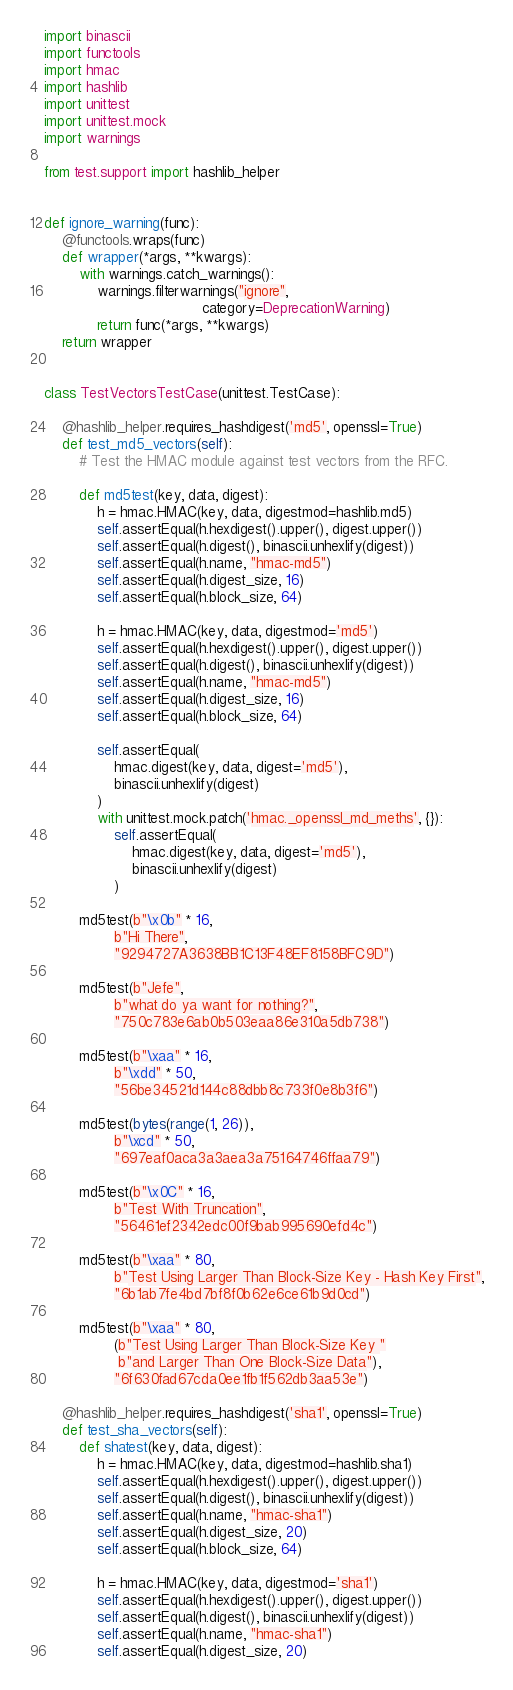Convert code to text. <code><loc_0><loc_0><loc_500><loc_500><_Python_>import binascii
import functools
import hmac
import hashlib
import unittest
import unittest.mock
import warnings

from test.support import hashlib_helper


def ignore_warning(func):
    @functools.wraps(func)
    def wrapper(*args, **kwargs):
        with warnings.catch_warnings():
            warnings.filterwarnings("ignore",
                                    category=DeprecationWarning)
            return func(*args, **kwargs)
    return wrapper


class TestVectorsTestCase(unittest.TestCase):

    @hashlib_helper.requires_hashdigest('md5', openssl=True)
    def test_md5_vectors(self):
        # Test the HMAC module against test vectors from the RFC.

        def md5test(key, data, digest):
            h = hmac.HMAC(key, data, digestmod=hashlib.md5)
            self.assertEqual(h.hexdigest().upper(), digest.upper())
            self.assertEqual(h.digest(), binascii.unhexlify(digest))
            self.assertEqual(h.name, "hmac-md5")
            self.assertEqual(h.digest_size, 16)
            self.assertEqual(h.block_size, 64)

            h = hmac.HMAC(key, data, digestmod='md5')
            self.assertEqual(h.hexdigest().upper(), digest.upper())
            self.assertEqual(h.digest(), binascii.unhexlify(digest))
            self.assertEqual(h.name, "hmac-md5")
            self.assertEqual(h.digest_size, 16)
            self.assertEqual(h.block_size, 64)

            self.assertEqual(
                hmac.digest(key, data, digest='md5'),
                binascii.unhexlify(digest)
            )
            with unittest.mock.patch('hmac._openssl_md_meths', {}):
                self.assertEqual(
                    hmac.digest(key, data, digest='md5'),
                    binascii.unhexlify(digest)
                )

        md5test(b"\x0b" * 16,
                b"Hi There",
                "9294727A3638BB1C13F48EF8158BFC9D")

        md5test(b"Jefe",
                b"what do ya want for nothing?",
                "750c783e6ab0b503eaa86e310a5db738")

        md5test(b"\xaa" * 16,
                b"\xdd" * 50,
                "56be34521d144c88dbb8c733f0e8b3f6")

        md5test(bytes(range(1, 26)),
                b"\xcd" * 50,
                "697eaf0aca3a3aea3a75164746ffaa79")

        md5test(b"\x0C" * 16,
                b"Test With Truncation",
                "56461ef2342edc00f9bab995690efd4c")

        md5test(b"\xaa" * 80,
                b"Test Using Larger Than Block-Size Key - Hash Key First",
                "6b1ab7fe4bd7bf8f0b62e6ce61b9d0cd")

        md5test(b"\xaa" * 80,
                (b"Test Using Larger Than Block-Size Key "
                 b"and Larger Than One Block-Size Data"),
                "6f630fad67cda0ee1fb1f562db3aa53e")

    @hashlib_helper.requires_hashdigest('sha1', openssl=True)
    def test_sha_vectors(self):
        def shatest(key, data, digest):
            h = hmac.HMAC(key, data, digestmod=hashlib.sha1)
            self.assertEqual(h.hexdigest().upper(), digest.upper())
            self.assertEqual(h.digest(), binascii.unhexlify(digest))
            self.assertEqual(h.name, "hmac-sha1")
            self.assertEqual(h.digest_size, 20)
            self.assertEqual(h.block_size, 64)

            h = hmac.HMAC(key, data, digestmod='sha1')
            self.assertEqual(h.hexdigest().upper(), digest.upper())
            self.assertEqual(h.digest(), binascii.unhexlify(digest))
            self.assertEqual(h.name, "hmac-sha1")
            self.assertEqual(h.digest_size, 20)</code> 